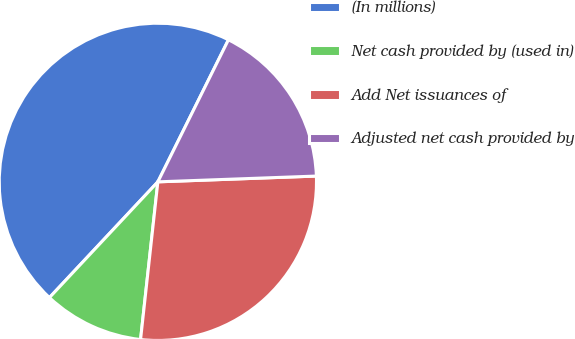<chart> <loc_0><loc_0><loc_500><loc_500><pie_chart><fcel>(In millions)<fcel>Net cash provided by (used in)<fcel>Add Net issuances of<fcel>Adjusted net cash provided by<nl><fcel>45.36%<fcel>10.24%<fcel>27.32%<fcel>17.08%<nl></chart> 